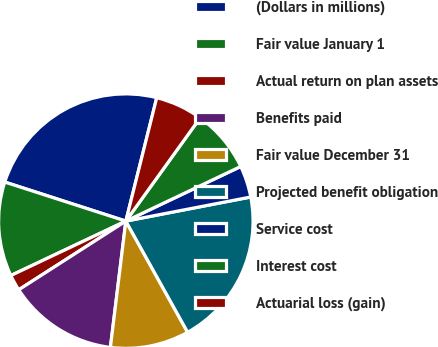Convert chart to OTSL. <chart><loc_0><loc_0><loc_500><loc_500><pie_chart><fcel>(Dollars in millions)<fcel>Fair value January 1<fcel>Actual return on plan assets<fcel>Benefits paid<fcel>Fair value December 31<fcel>Projected benefit obligation<fcel>Service cost<fcel>Interest cost<fcel>Actuarial loss (gain)<nl><fcel>23.94%<fcel>12.0%<fcel>2.04%<fcel>13.99%<fcel>10.01%<fcel>19.96%<fcel>4.03%<fcel>8.01%<fcel>6.02%<nl></chart> 